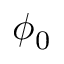Convert formula to latex. <formula><loc_0><loc_0><loc_500><loc_500>\phi _ { 0 }</formula> 